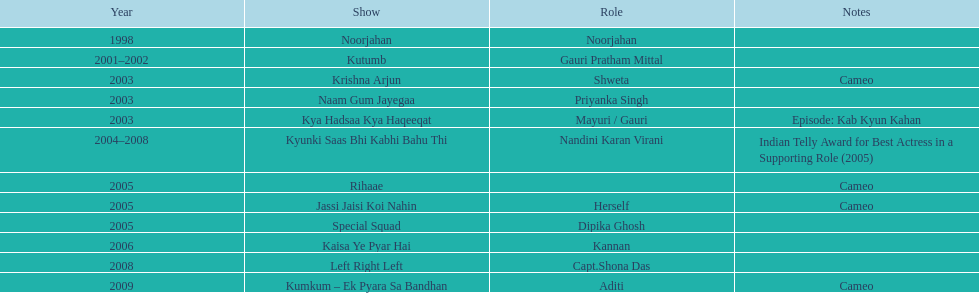Which television show was gauri in for the longest amount of time? Kyunki Saas Bhi Kabhi Bahu Thi. 